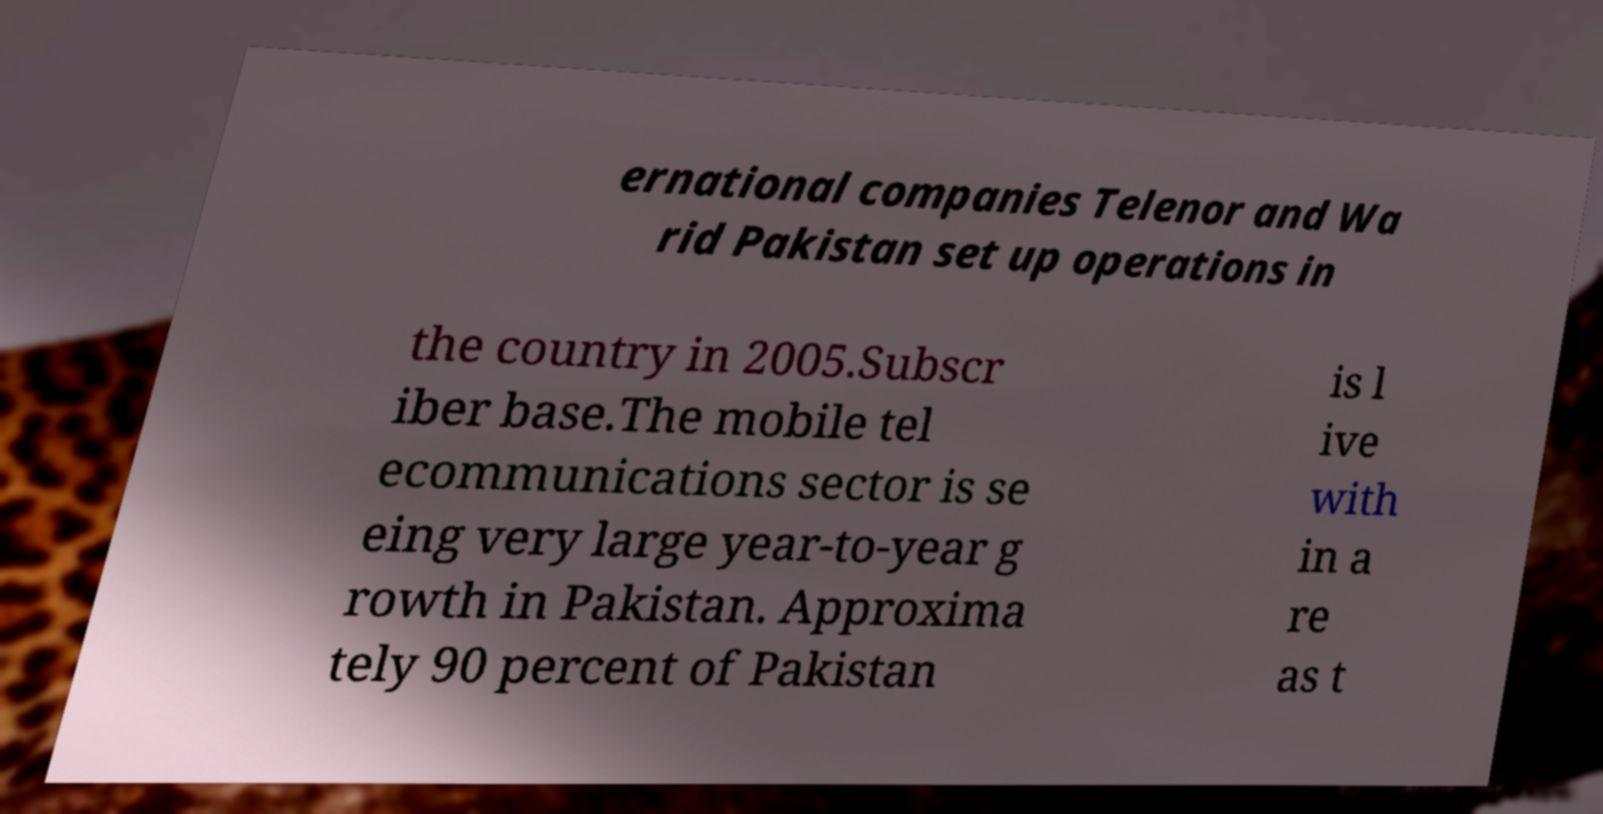Could you assist in decoding the text presented in this image and type it out clearly? ernational companies Telenor and Wa rid Pakistan set up operations in the country in 2005.Subscr iber base.The mobile tel ecommunications sector is se eing very large year-to-year g rowth in Pakistan. Approxima tely 90 percent of Pakistan is l ive with in a re as t 